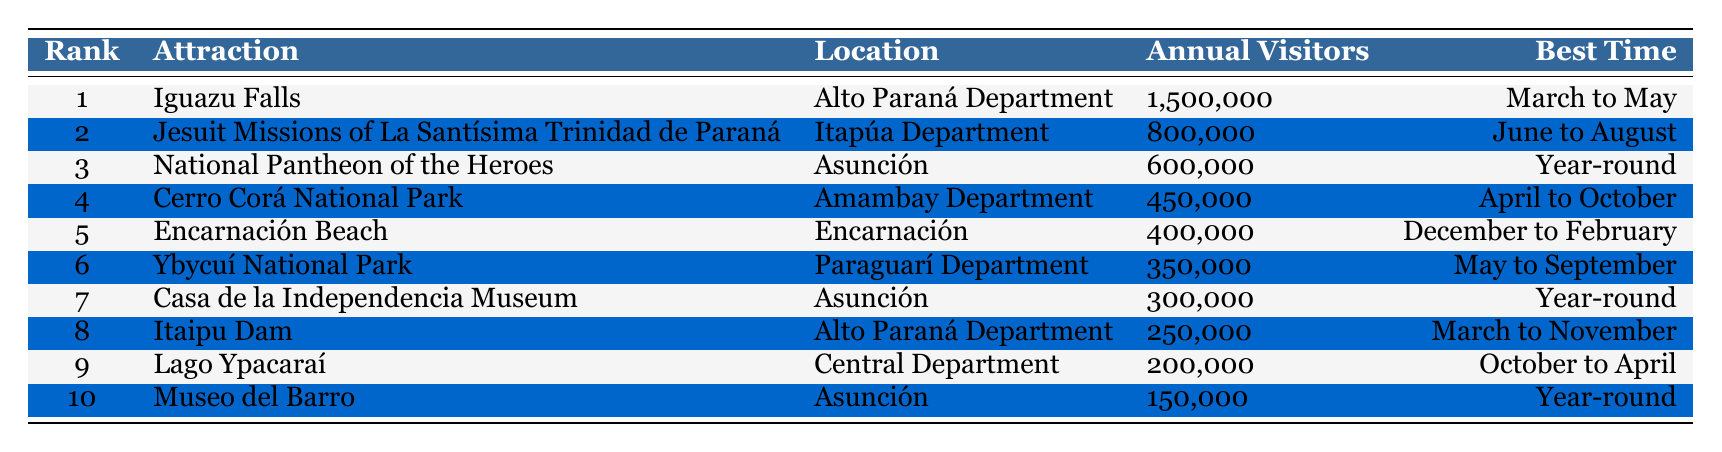What is the most visited tourist attraction in Paraguay? The table indicates that Iguazu Falls has the highest number of annual visitors at 1,500,000, making it the most visited attraction.
Answer: Iguazu Falls Which location has the second highest number of annual visitors? According to the table, the Jesuit Missions of La Santísima Trinidad de Paraná, located in the Itapúa Department, has 800,000 annual visitors, making it the second most visited.
Answer: Jesuit Missions of La Santísima Trinidad de Paraná Is Lago Ypacaraí the least visited attraction on the list? The table shows Lago Ypacaraí has 200,000 annual visitors, but the Museo del Barro has only 150,000. Therefore, Lago Ypacaraí is not the least visited; Museo del Barro is.
Answer: No How many more visitors does the National Pantheon of the Heroes have compared to the Itaipu Dam? The National Pantheon of the Heroes has 600,000 visitors while the Itaipu Dam has 250,000. The difference is 600,000 - 250,000 = 350,000.
Answer: 350000 What is the average number of annual visitors for the top three attractions? The top three attractions have the following visitors: 1,500,000 for Iguazu Falls, 800,000 for the Jesuit Missions, and 600,000 for the National Pantheon. The total is 1,500,000 + 800,000 + 600,000 = 2,900,000. Dividing by 3 gives an average of 966,667.
Answer: 966667 What is the best time to visit the attractions in Asunción? There are three attractions in Asunción: the National Pantheon of the Heroes, Casa de la Independencia Museum, and Museo del Barro. Two of them are best visited year-round, while the best time for the National Pantheon is also year-round, suggesting it’s a good time any time of the year.
Answer: Year-round How many attractions can be visited from March to May? Referring to the table, Iguazu Falls can be visited from March to May. Additionally, the Itaipu Dam can be visited from March to November, which overlaps with this period. Therefore, there are two attractions available during this timeframe.
Answer: 2 Which attraction has the lowest number of annual visitors? Based on the table, Museo del Barro has the lowest with 150,000 visitors.
Answer: Museo del Barro What is the total number of visitors for attractions located in the Alto Paraná Department? The attractions in the Alto Paraná Department are Iguazu Falls (1,500,000) and Itaipu Dam (250,000). Summing these gives 1,500,000 + 250,000 = 1,750,000.
Answer: 1750000 